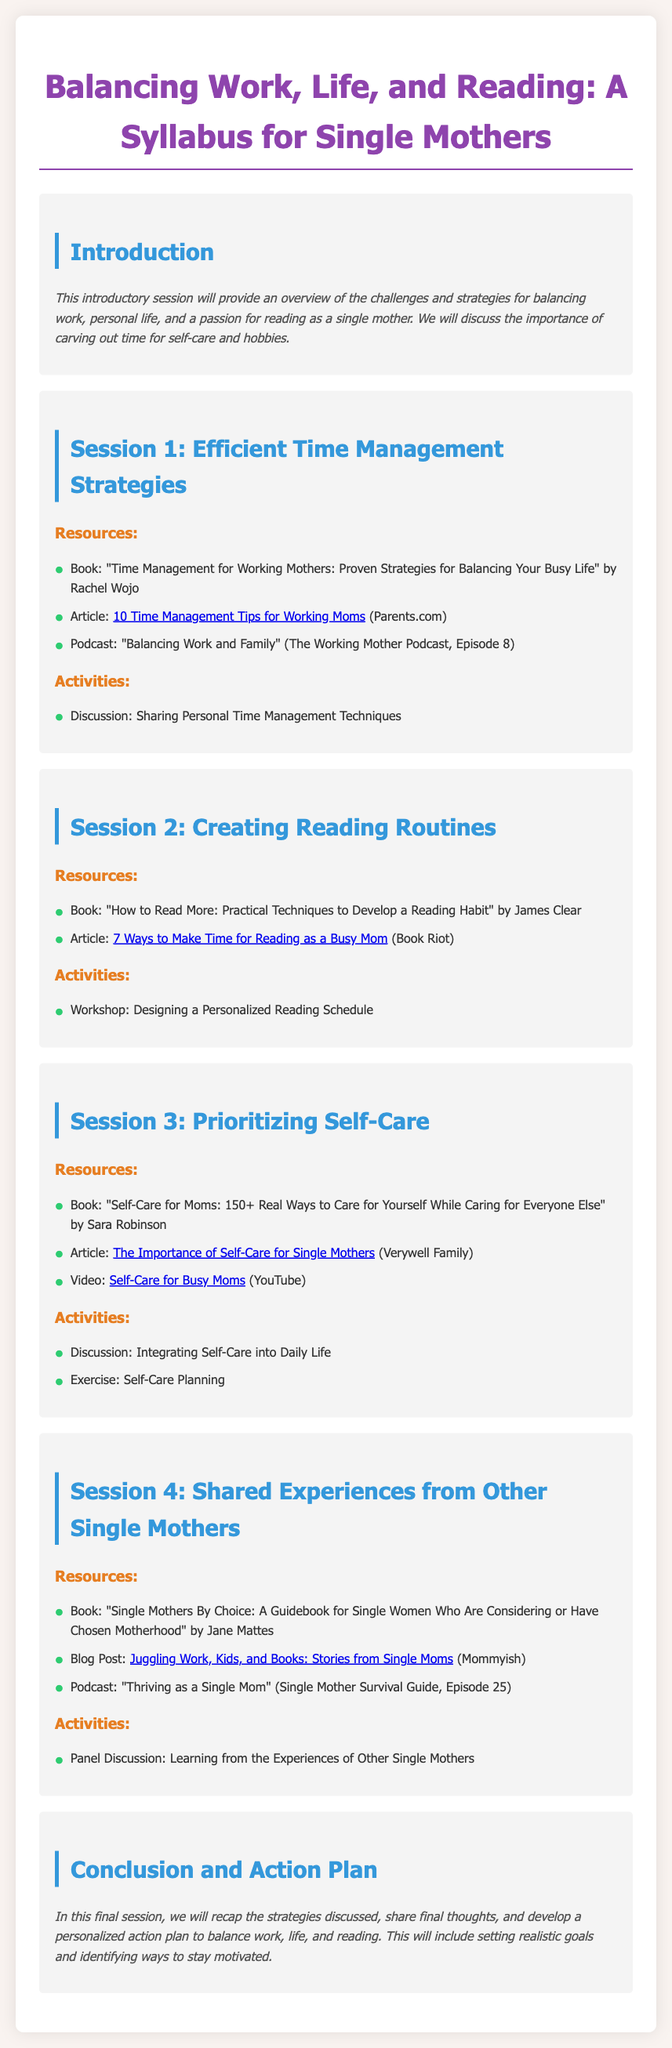What is the title of the syllabus? The title of the syllabus is mentioned at the top of the document, indicating its focus area.
Answer: Balancing Work, Life, and Reading: A Syllabus for Single Mothers How many sessions are included in the syllabus? The syllabus outlines multiple sessions, and counting them will provide the total number.
Answer: 5 What is the main topic of Session 3? The main topic of each session is specified in the session headings.
Answer: Prioritizing Self-Care Which book is recommended in Session 1? Each session provides suggested readings, including books relevant to the topic.
Answer: Time Management for Working Mothers: Proven Strategies for Balancing Your Busy Life What type of activity is included in Session 4? The activities in each session indicate how participants will engage with the material.
Answer: Panel Discussion: Learning from the Experiences of Other Single Mothers What is the focus of the final session? The conclusion typically summarizes the content of the syllabus and outlines final actions.
Answer: Conclusion and Action Plan What resource discusses making time for reading? The syllabus lists specific resources related to each session's topic.
Answer: 7 Ways to Make Time for Reading as a Busy Mom Which podcast episode is mentioned in Session 2? Each session may include multimedia resources like podcasts to enhance learning on the subject.
Answer: Balancing Work and Family (The Working Mother Podcast, Episode 8) What is one of the articles linked in Session 3? Articles serve as readings that complement the session's discussions and activities.
Answer: The Importance of Self-Care for Single Mothers 